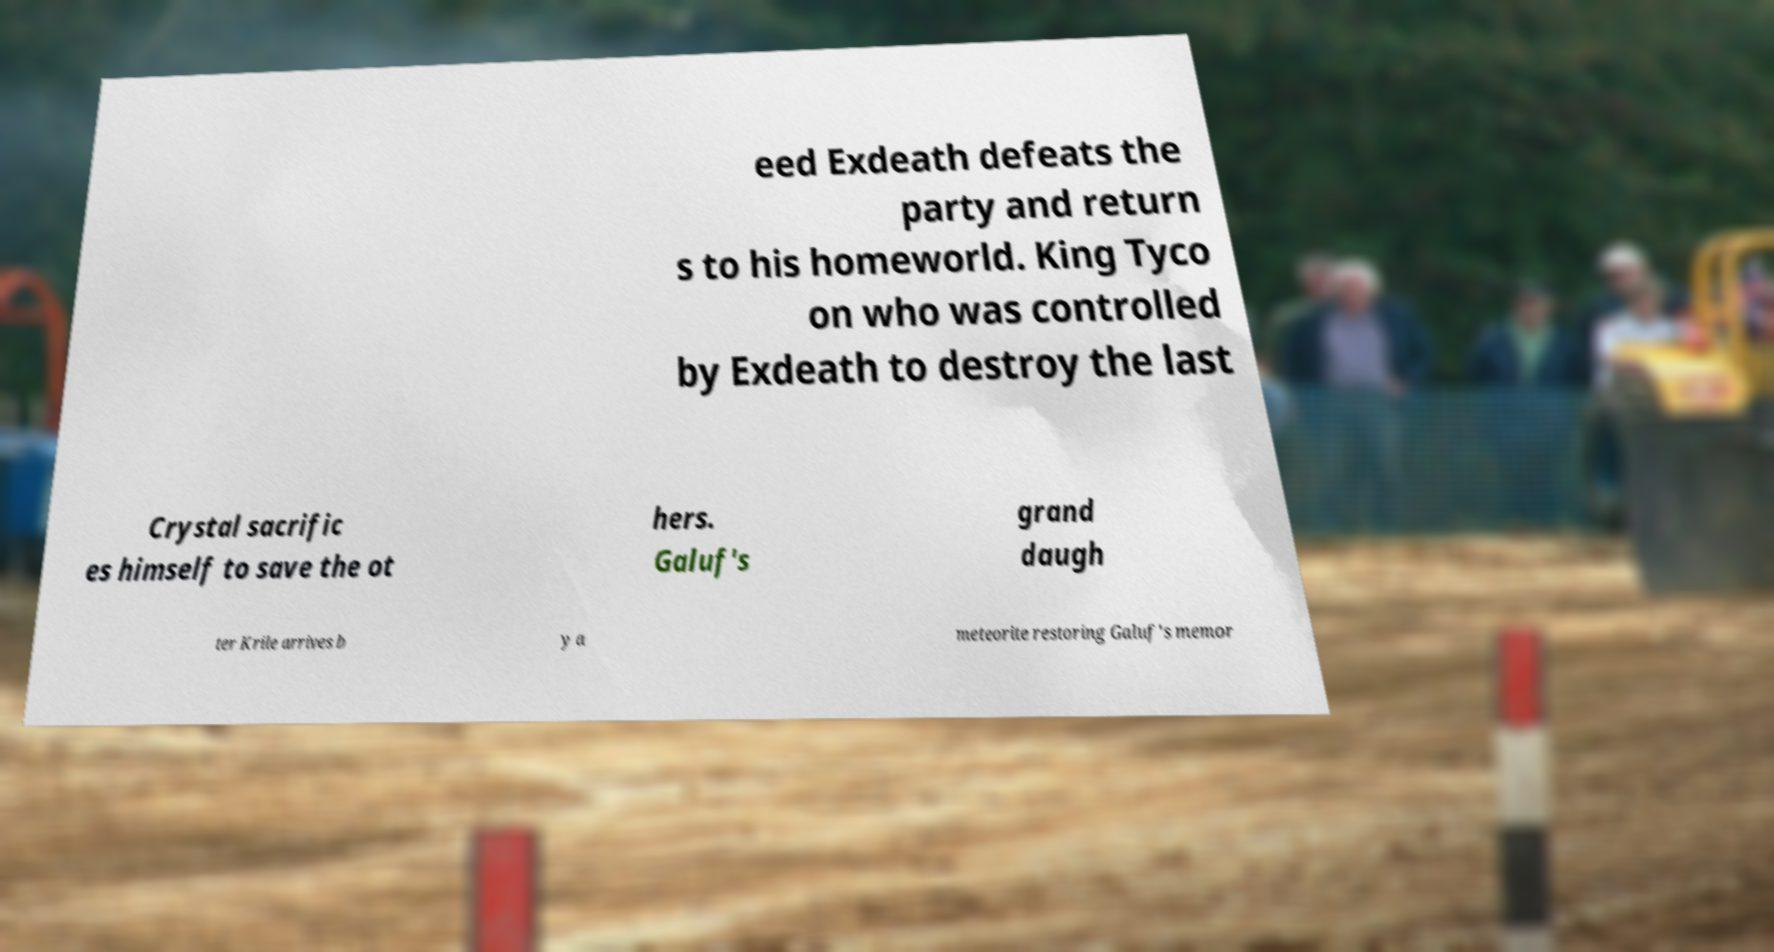Can you read and provide the text displayed in the image?This photo seems to have some interesting text. Can you extract and type it out for me? eed Exdeath defeats the party and return s to his homeworld. King Tyco on who was controlled by Exdeath to destroy the last Crystal sacrific es himself to save the ot hers. Galuf's grand daugh ter Krile arrives b y a meteorite restoring Galuf's memor 